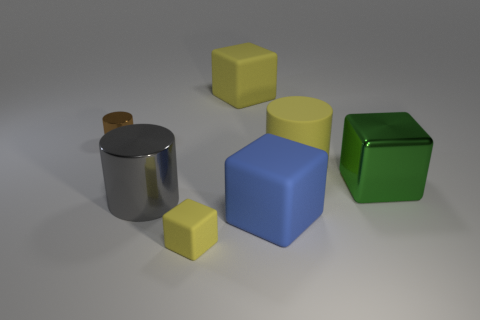Add 2 gray cylinders. How many objects exist? 9 Subtract all blocks. How many objects are left? 3 Add 4 large green shiny things. How many large green shiny things exist? 5 Subtract 0 purple cylinders. How many objects are left? 7 Subtract all brown rubber cylinders. Subtract all tiny matte things. How many objects are left? 6 Add 5 yellow things. How many yellow things are left? 8 